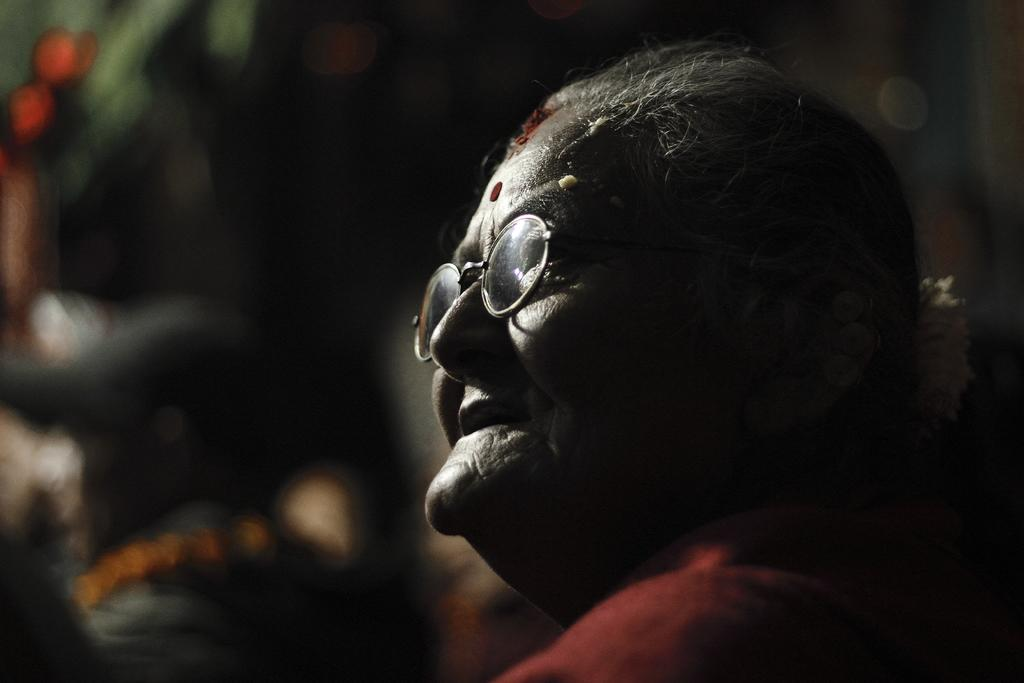Who is the main subject in the image? There is an old woman in the image. What is the old woman doing in the image? The old woman is smiling. Can you describe the background of the image? The background of the image appears blurry. How many toes can be seen on the old woman's feet in the image? There is no visible indication of the old woman's feet or toes in the image. 